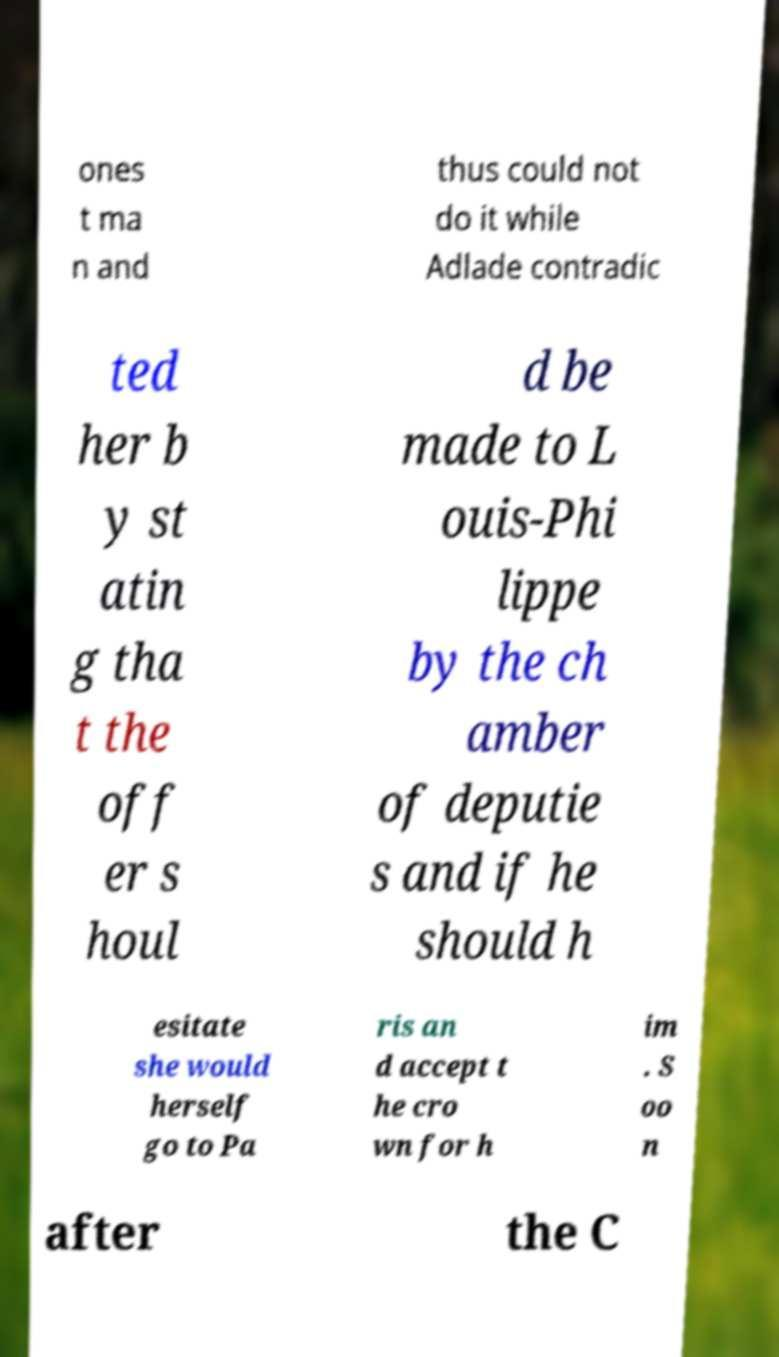Could you extract and type out the text from this image? ones t ma n and thus could not do it while Adlade contradic ted her b y st atin g tha t the off er s houl d be made to L ouis-Phi lippe by the ch amber of deputie s and if he should h esitate she would herself go to Pa ris an d accept t he cro wn for h im . S oo n after the C 